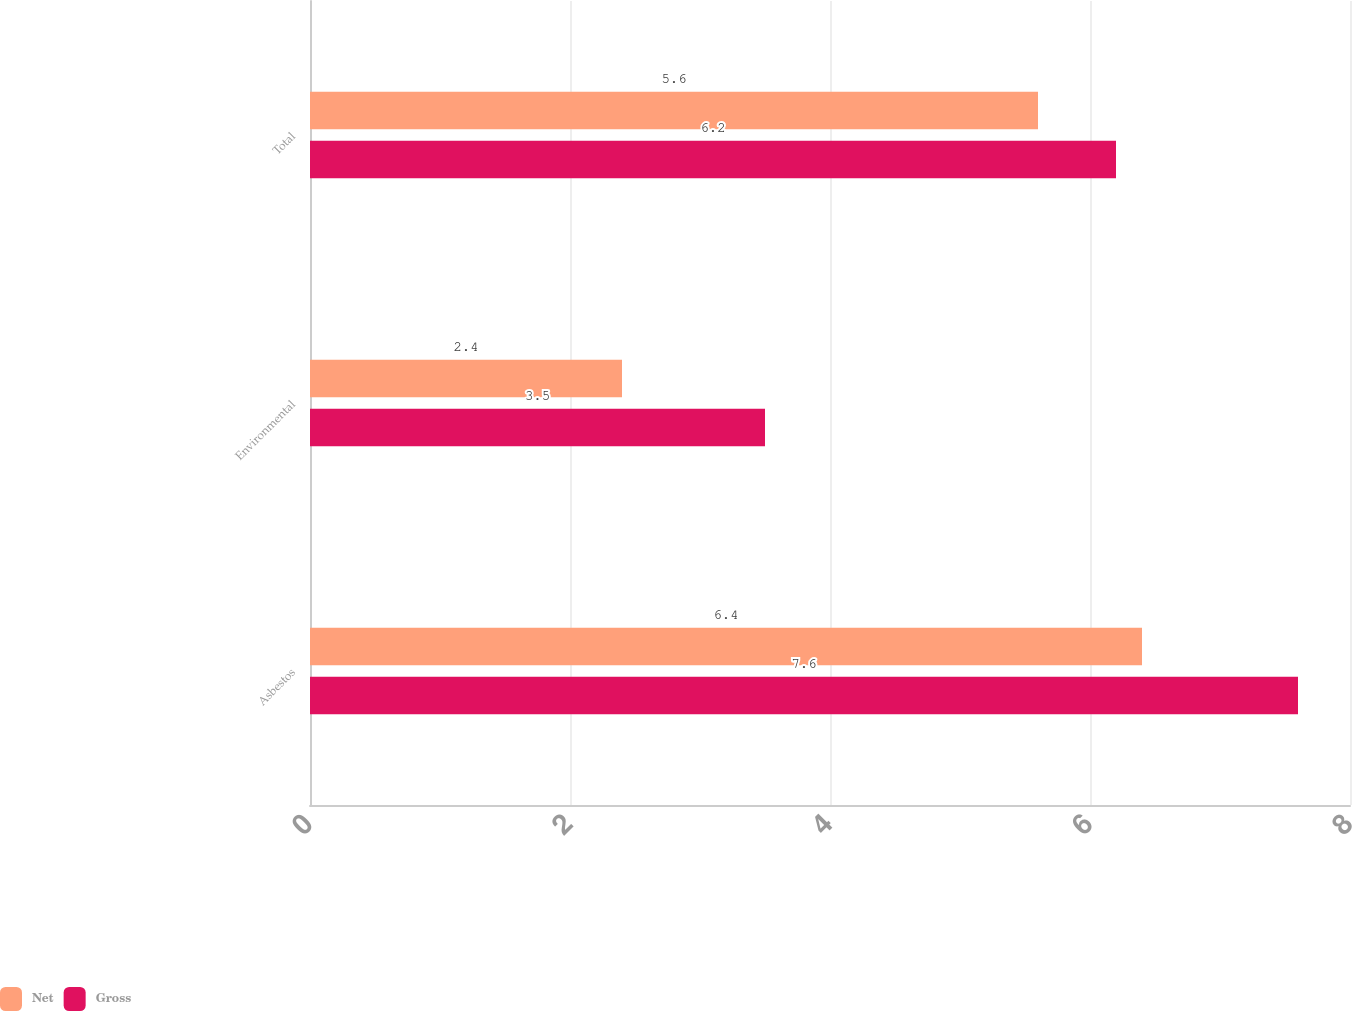Convert chart. <chart><loc_0><loc_0><loc_500><loc_500><stacked_bar_chart><ecel><fcel>Asbestos<fcel>Environmental<fcel>Total<nl><fcel>Net<fcel>6.4<fcel>2.4<fcel>5.6<nl><fcel>Gross<fcel>7.6<fcel>3.5<fcel>6.2<nl></chart> 